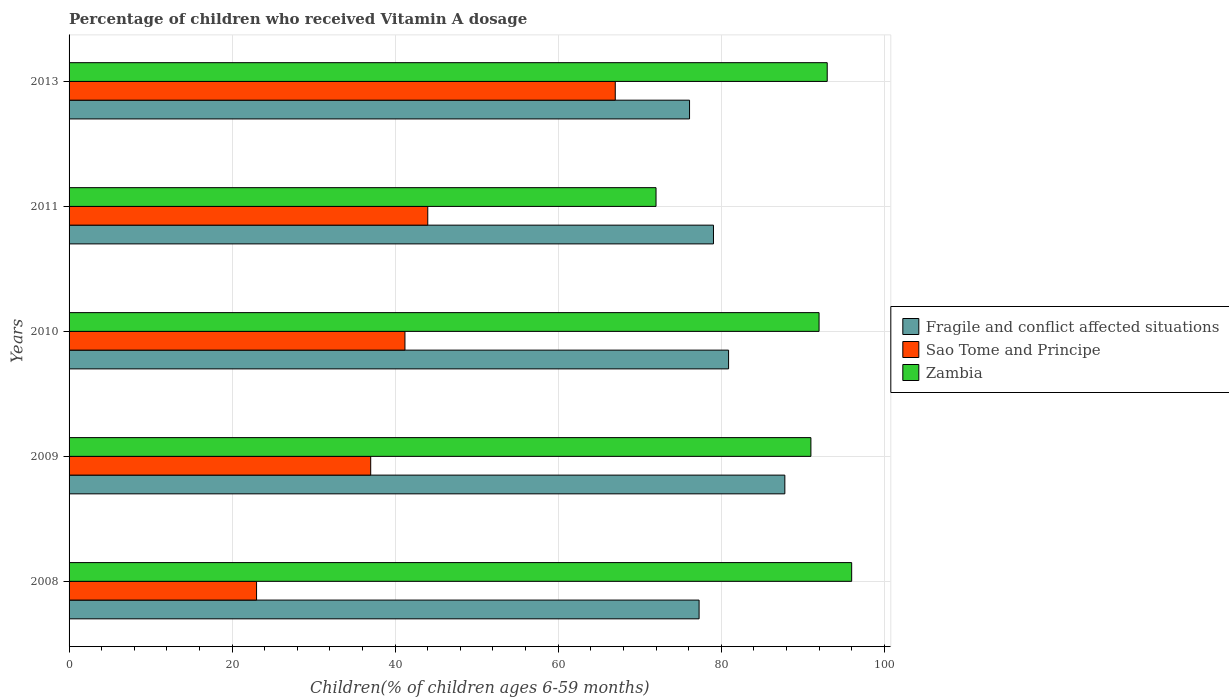How many groups of bars are there?
Provide a short and direct response. 5. How many bars are there on the 2nd tick from the top?
Provide a short and direct response. 3. What is the label of the 1st group of bars from the top?
Provide a short and direct response. 2013. Across all years, what is the minimum percentage of children who received Vitamin A dosage in Fragile and conflict affected situations?
Offer a terse response. 76.11. In which year was the percentage of children who received Vitamin A dosage in Sao Tome and Principe maximum?
Offer a very short reply. 2013. What is the total percentage of children who received Vitamin A dosage in Fragile and conflict affected situations in the graph?
Keep it short and to the point. 401.15. What is the difference between the percentage of children who received Vitamin A dosage in Zambia in 2010 and that in 2013?
Offer a very short reply. -1. What is the difference between the percentage of children who received Vitamin A dosage in Zambia in 2009 and the percentage of children who received Vitamin A dosage in Fragile and conflict affected situations in 2008?
Offer a terse response. 13.72. What is the average percentage of children who received Vitamin A dosage in Zambia per year?
Provide a succinct answer. 88.8. In the year 2011, what is the difference between the percentage of children who received Vitamin A dosage in Zambia and percentage of children who received Vitamin A dosage in Fragile and conflict affected situations?
Provide a short and direct response. -7.05. What is the ratio of the percentage of children who received Vitamin A dosage in Fragile and conflict affected situations in 2008 to that in 2009?
Your response must be concise. 0.88. Is the percentage of children who received Vitamin A dosage in Sao Tome and Principe in 2008 less than that in 2009?
Provide a short and direct response. Yes. What is the difference between the highest and the second highest percentage of children who received Vitamin A dosage in Fragile and conflict affected situations?
Offer a very short reply. 6.9. Is the sum of the percentage of children who received Vitamin A dosage in Zambia in 2008 and 2010 greater than the maximum percentage of children who received Vitamin A dosage in Fragile and conflict affected situations across all years?
Give a very brief answer. Yes. What does the 3rd bar from the top in 2010 represents?
Provide a succinct answer. Fragile and conflict affected situations. What does the 2nd bar from the bottom in 2011 represents?
Make the answer very short. Sao Tome and Principe. Is it the case that in every year, the sum of the percentage of children who received Vitamin A dosage in Zambia and percentage of children who received Vitamin A dosage in Fragile and conflict affected situations is greater than the percentage of children who received Vitamin A dosage in Sao Tome and Principe?
Provide a short and direct response. Yes. How many bars are there?
Offer a terse response. 15. How many years are there in the graph?
Your answer should be compact. 5. What is the difference between two consecutive major ticks on the X-axis?
Give a very brief answer. 20. Does the graph contain any zero values?
Offer a terse response. No. Where does the legend appear in the graph?
Keep it short and to the point. Center right. How are the legend labels stacked?
Your answer should be compact. Vertical. What is the title of the graph?
Your answer should be very brief. Percentage of children who received Vitamin A dosage. Does "South Asia" appear as one of the legend labels in the graph?
Offer a terse response. No. What is the label or title of the X-axis?
Keep it short and to the point. Children(% of children ages 6-59 months). What is the Children(% of children ages 6-59 months) of Fragile and conflict affected situations in 2008?
Make the answer very short. 77.28. What is the Children(% of children ages 6-59 months) of Zambia in 2008?
Your answer should be very brief. 96. What is the Children(% of children ages 6-59 months) of Fragile and conflict affected situations in 2009?
Your response must be concise. 87.8. What is the Children(% of children ages 6-59 months) of Zambia in 2009?
Offer a very short reply. 91. What is the Children(% of children ages 6-59 months) in Fragile and conflict affected situations in 2010?
Your response must be concise. 80.9. What is the Children(% of children ages 6-59 months) of Sao Tome and Principe in 2010?
Your answer should be compact. 41.2. What is the Children(% of children ages 6-59 months) in Zambia in 2010?
Provide a short and direct response. 92. What is the Children(% of children ages 6-59 months) of Fragile and conflict affected situations in 2011?
Ensure brevity in your answer.  79.05. What is the Children(% of children ages 6-59 months) of Zambia in 2011?
Make the answer very short. 72. What is the Children(% of children ages 6-59 months) of Fragile and conflict affected situations in 2013?
Your answer should be compact. 76.11. What is the Children(% of children ages 6-59 months) of Sao Tome and Principe in 2013?
Your response must be concise. 67. What is the Children(% of children ages 6-59 months) of Zambia in 2013?
Provide a short and direct response. 93. Across all years, what is the maximum Children(% of children ages 6-59 months) in Fragile and conflict affected situations?
Your response must be concise. 87.8. Across all years, what is the maximum Children(% of children ages 6-59 months) of Sao Tome and Principe?
Keep it short and to the point. 67. Across all years, what is the maximum Children(% of children ages 6-59 months) in Zambia?
Give a very brief answer. 96. Across all years, what is the minimum Children(% of children ages 6-59 months) of Fragile and conflict affected situations?
Make the answer very short. 76.11. Across all years, what is the minimum Children(% of children ages 6-59 months) in Zambia?
Your answer should be compact. 72. What is the total Children(% of children ages 6-59 months) of Fragile and conflict affected situations in the graph?
Offer a terse response. 401.15. What is the total Children(% of children ages 6-59 months) of Sao Tome and Principe in the graph?
Your answer should be compact. 212.2. What is the total Children(% of children ages 6-59 months) of Zambia in the graph?
Offer a very short reply. 444. What is the difference between the Children(% of children ages 6-59 months) in Fragile and conflict affected situations in 2008 and that in 2009?
Offer a very short reply. -10.52. What is the difference between the Children(% of children ages 6-59 months) of Sao Tome and Principe in 2008 and that in 2009?
Your response must be concise. -14. What is the difference between the Children(% of children ages 6-59 months) in Zambia in 2008 and that in 2009?
Give a very brief answer. 5. What is the difference between the Children(% of children ages 6-59 months) in Fragile and conflict affected situations in 2008 and that in 2010?
Your answer should be very brief. -3.62. What is the difference between the Children(% of children ages 6-59 months) of Sao Tome and Principe in 2008 and that in 2010?
Keep it short and to the point. -18.2. What is the difference between the Children(% of children ages 6-59 months) of Fragile and conflict affected situations in 2008 and that in 2011?
Give a very brief answer. -1.76. What is the difference between the Children(% of children ages 6-59 months) in Sao Tome and Principe in 2008 and that in 2011?
Your answer should be very brief. -21. What is the difference between the Children(% of children ages 6-59 months) in Fragile and conflict affected situations in 2008 and that in 2013?
Give a very brief answer. 1.17. What is the difference between the Children(% of children ages 6-59 months) in Sao Tome and Principe in 2008 and that in 2013?
Offer a very short reply. -44. What is the difference between the Children(% of children ages 6-59 months) in Fragile and conflict affected situations in 2009 and that in 2010?
Offer a terse response. 6.9. What is the difference between the Children(% of children ages 6-59 months) of Sao Tome and Principe in 2009 and that in 2010?
Give a very brief answer. -4.2. What is the difference between the Children(% of children ages 6-59 months) of Zambia in 2009 and that in 2010?
Your response must be concise. -1. What is the difference between the Children(% of children ages 6-59 months) in Fragile and conflict affected situations in 2009 and that in 2011?
Your answer should be compact. 8.76. What is the difference between the Children(% of children ages 6-59 months) in Sao Tome and Principe in 2009 and that in 2011?
Provide a short and direct response. -7. What is the difference between the Children(% of children ages 6-59 months) of Zambia in 2009 and that in 2011?
Make the answer very short. 19. What is the difference between the Children(% of children ages 6-59 months) of Fragile and conflict affected situations in 2009 and that in 2013?
Offer a terse response. 11.69. What is the difference between the Children(% of children ages 6-59 months) in Sao Tome and Principe in 2009 and that in 2013?
Your answer should be very brief. -30. What is the difference between the Children(% of children ages 6-59 months) of Fragile and conflict affected situations in 2010 and that in 2011?
Provide a succinct answer. 1.85. What is the difference between the Children(% of children ages 6-59 months) in Sao Tome and Principe in 2010 and that in 2011?
Provide a short and direct response. -2.8. What is the difference between the Children(% of children ages 6-59 months) in Fragile and conflict affected situations in 2010 and that in 2013?
Your answer should be compact. 4.79. What is the difference between the Children(% of children ages 6-59 months) in Sao Tome and Principe in 2010 and that in 2013?
Your answer should be compact. -25.8. What is the difference between the Children(% of children ages 6-59 months) of Fragile and conflict affected situations in 2011 and that in 2013?
Offer a terse response. 2.93. What is the difference between the Children(% of children ages 6-59 months) in Sao Tome and Principe in 2011 and that in 2013?
Offer a terse response. -23. What is the difference between the Children(% of children ages 6-59 months) in Fragile and conflict affected situations in 2008 and the Children(% of children ages 6-59 months) in Sao Tome and Principe in 2009?
Give a very brief answer. 40.28. What is the difference between the Children(% of children ages 6-59 months) of Fragile and conflict affected situations in 2008 and the Children(% of children ages 6-59 months) of Zambia in 2009?
Give a very brief answer. -13.72. What is the difference between the Children(% of children ages 6-59 months) in Sao Tome and Principe in 2008 and the Children(% of children ages 6-59 months) in Zambia in 2009?
Offer a very short reply. -68. What is the difference between the Children(% of children ages 6-59 months) in Fragile and conflict affected situations in 2008 and the Children(% of children ages 6-59 months) in Sao Tome and Principe in 2010?
Provide a short and direct response. 36.08. What is the difference between the Children(% of children ages 6-59 months) of Fragile and conflict affected situations in 2008 and the Children(% of children ages 6-59 months) of Zambia in 2010?
Provide a short and direct response. -14.72. What is the difference between the Children(% of children ages 6-59 months) in Sao Tome and Principe in 2008 and the Children(% of children ages 6-59 months) in Zambia in 2010?
Offer a very short reply. -69. What is the difference between the Children(% of children ages 6-59 months) of Fragile and conflict affected situations in 2008 and the Children(% of children ages 6-59 months) of Sao Tome and Principe in 2011?
Provide a short and direct response. 33.28. What is the difference between the Children(% of children ages 6-59 months) of Fragile and conflict affected situations in 2008 and the Children(% of children ages 6-59 months) of Zambia in 2011?
Give a very brief answer. 5.28. What is the difference between the Children(% of children ages 6-59 months) in Sao Tome and Principe in 2008 and the Children(% of children ages 6-59 months) in Zambia in 2011?
Give a very brief answer. -49. What is the difference between the Children(% of children ages 6-59 months) of Fragile and conflict affected situations in 2008 and the Children(% of children ages 6-59 months) of Sao Tome and Principe in 2013?
Keep it short and to the point. 10.28. What is the difference between the Children(% of children ages 6-59 months) of Fragile and conflict affected situations in 2008 and the Children(% of children ages 6-59 months) of Zambia in 2013?
Ensure brevity in your answer.  -15.72. What is the difference between the Children(% of children ages 6-59 months) of Sao Tome and Principe in 2008 and the Children(% of children ages 6-59 months) of Zambia in 2013?
Provide a succinct answer. -70. What is the difference between the Children(% of children ages 6-59 months) of Fragile and conflict affected situations in 2009 and the Children(% of children ages 6-59 months) of Sao Tome and Principe in 2010?
Make the answer very short. 46.6. What is the difference between the Children(% of children ages 6-59 months) of Fragile and conflict affected situations in 2009 and the Children(% of children ages 6-59 months) of Zambia in 2010?
Provide a short and direct response. -4.2. What is the difference between the Children(% of children ages 6-59 months) in Sao Tome and Principe in 2009 and the Children(% of children ages 6-59 months) in Zambia in 2010?
Ensure brevity in your answer.  -55. What is the difference between the Children(% of children ages 6-59 months) in Fragile and conflict affected situations in 2009 and the Children(% of children ages 6-59 months) in Sao Tome and Principe in 2011?
Your response must be concise. 43.8. What is the difference between the Children(% of children ages 6-59 months) in Fragile and conflict affected situations in 2009 and the Children(% of children ages 6-59 months) in Zambia in 2011?
Offer a terse response. 15.8. What is the difference between the Children(% of children ages 6-59 months) of Sao Tome and Principe in 2009 and the Children(% of children ages 6-59 months) of Zambia in 2011?
Provide a short and direct response. -35. What is the difference between the Children(% of children ages 6-59 months) of Fragile and conflict affected situations in 2009 and the Children(% of children ages 6-59 months) of Sao Tome and Principe in 2013?
Provide a short and direct response. 20.8. What is the difference between the Children(% of children ages 6-59 months) in Fragile and conflict affected situations in 2009 and the Children(% of children ages 6-59 months) in Zambia in 2013?
Your answer should be very brief. -5.2. What is the difference between the Children(% of children ages 6-59 months) of Sao Tome and Principe in 2009 and the Children(% of children ages 6-59 months) of Zambia in 2013?
Ensure brevity in your answer.  -56. What is the difference between the Children(% of children ages 6-59 months) of Fragile and conflict affected situations in 2010 and the Children(% of children ages 6-59 months) of Sao Tome and Principe in 2011?
Provide a succinct answer. 36.9. What is the difference between the Children(% of children ages 6-59 months) of Fragile and conflict affected situations in 2010 and the Children(% of children ages 6-59 months) of Zambia in 2011?
Make the answer very short. 8.9. What is the difference between the Children(% of children ages 6-59 months) of Sao Tome and Principe in 2010 and the Children(% of children ages 6-59 months) of Zambia in 2011?
Keep it short and to the point. -30.8. What is the difference between the Children(% of children ages 6-59 months) in Fragile and conflict affected situations in 2010 and the Children(% of children ages 6-59 months) in Sao Tome and Principe in 2013?
Offer a terse response. 13.9. What is the difference between the Children(% of children ages 6-59 months) in Fragile and conflict affected situations in 2010 and the Children(% of children ages 6-59 months) in Zambia in 2013?
Provide a short and direct response. -12.1. What is the difference between the Children(% of children ages 6-59 months) of Sao Tome and Principe in 2010 and the Children(% of children ages 6-59 months) of Zambia in 2013?
Give a very brief answer. -51.8. What is the difference between the Children(% of children ages 6-59 months) of Fragile and conflict affected situations in 2011 and the Children(% of children ages 6-59 months) of Sao Tome and Principe in 2013?
Your response must be concise. 12.05. What is the difference between the Children(% of children ages 6-59 months) of Fragile and conflict affected situations in 2011 and the Children(% of children ages 6-59 months) of Zambia in 2013?
Your answer should be compact. -13.95. What is the difference between the Children(% of children ages 6-59 months) in Sao Tome and Principe in 2011 and the Children(% of children ages 6-59 months) in Zambia in 2013?
Offer a terse response. -49. What is the average Children(% of children ages 6-59 months) of Fragile and conflict affected situations per year?
Offer a terse response. 80.23. What is the average Children(% of children ages 6-59 months) of Sao Tome and Principe per year?
Provide a short and direct response. 42.44. What is the average Children(% of children ages 6-59 months) of Zambia per year?
Make the answer very short. 88.8. In the year 2008, what is the difference between the Children(% of children ages 6-59 months) of Fragile and conflict affected situations and Children(% of children ages 6-59 months) of Sao Tome and Principe?
Offer a terse response. 54.28. In the year 2008, what is the difference between the Children(% of children ages 6-59 months) of Fragile and conflict affected situations and Children(% of children ages 6-59 months) of Zambia?
Offer a very short reply. -18.72. In the year 2008, what is the difference between the Children(% of children ages 6-59 months) in Sao Tome and Principe and Children(% of children ages 6-59 months) in Zambia?
Your response must be concise. -73. In the year 2009, what is the difference between the Children(% of children ages 6-59 months) of Fragile and conflict affected situations and Children(% of children ages 6-59 months) of Sao Tome and Principe?
Provide a short and direct response. 50.8. In the year 2009, what is the difference between the Children(% of children ages 6-59 months) in Fragile and conflict affected situations and Children(% of children ages 6-59 months) in Zambia?
Offer a very short reply. -3.2. In the year 2009, what is the difference between the Children(% of children ages 6-59 months) in Sao Tome and Principe and Children(% of children ages 6-59 months) in Zambia?
Provide a short and direct response. -54. In the year 2010, what is the difference between the Children(% of children ages 6-59 months) in Fragile and conflict affected situations and Children(% of children ages 6-59 months) in Sao Tome and Principe?
Make the answer very short. 39.7. In the year 2010, what is the difference between the Children(% of children ages 6-59 months) of Fragile and conflict affected situations and Children(% of children ages 6-59 months) of Zambia?
Ensure brevity in your answer.  -11.1. In the year 2010, what is the difference between the Children(% of children ages 6-59 months) in Sao Tome and Principe and Children(% of children ages 6-59 months) in Zambia?
Make the answer very short. -50.8. In the year 2011, what is the difference between the Children(% of children ages 6-59 months) in Fragile and conflict affected situations and Children(% of children ages 6-59 months) in Sao Tome and Principe?
Provide a succinct answer. 35.05. In the year 2011, what is the difference between the Children(% of children ages 6-59 months) in Fragile and conflict affected situations and Children(% of children ages 6-59 months) in Zambia?
Give a very brief answer. 7.05. In the year 2013, what is the difference between the Children(% of children ages 6-59 months) in Fragile and conflict affected situations and Children(% of children ages 6-59 months) in Sao Tome and Principe?
Provide a succinct answer. 9.11. In the year 2013, what is the difference between the Children(% of children ages 6-59 months) in Fragile and conflict affected situations and Children(% of children ages 6-59 months) in Zambia?
Make the answer very short. -16.89. What is the ratio of the Children(% of children ages 6-59 months) of Fragile and conflict affected situations in 2008 to that in 2009?
Your response must be concise. 0.88. What is the ratio of the Children(% of children ages 6-59 months) in Sao Tome and Principe in 2008 to that in 2009?
Offer a terse response. 0.62. What is the ratio of the Children(% of children ages 6-59 months) in Zambia in 2008 to that in 2009?
Provide a succinct answer. 1.05. What is the ratio of the Children(% of children ages 6-59 months) of Fragile and conflict affected situations in 2008 to that in 2010?
Offer a very short reply. 0.96. What is the ratio of the Children(% of children ages 6-59 months) of Sao Tome and Principe in 2008 to that in 2010?
Ensure brevity in your answer.  0.56. What is the ratio of the Children(% of children ages 6-59 months) of Zambia in 2008 to that in 2010?
Offer a terse response. 1.04. What is the ratio of the Children(% of children ages 6-59 months) in Fragile and conflict affected situations in 2008 to that in 2011?
Keep it short and to the point. 0.98. What is the ratio of the Children(% of children ages 6-59 months) of Sao Tome and Principe in 2008 to that in 2011?
Keep it short and to the point. 0.52. What is the ratio of the Children(% of children ages 6-59 months) of Fragile and conflict affected situations in 2008 to that in 2013?
Make the answer very short. 1.02. What is the ratio of the Children(% of children ages 6-59 months) of Sao Tome and Principe in 2008 to that in 2013?
Make the answer very short. 0.34. What is the ratio of the Children(% of children ages 6-59 months) in Zambia in 2008 to that in 2013?
Offer a very short reply. 1.03. What is the ratio of the Children(% of children ages 6-59 months) in Fragile and conflict affected situations in 2009 to that in 2010?
Your response must be concise. 1.09. What is the ratio of the Children(% of children ages 6-59 months) of Sao Tome and Principe in 2009 to that in 2010?
Offer a terse response. 0.9. What is the ratio of the Children(% of children ages 6-59 months) in Zambia in 2009 to that in 2010?
Ensure brevity in your answer.  0.99. What is the ratio of the Children(% of children ages 6-59 months) of Fragile and conflict affected situations in 2009 to that in 2011?
Your response must be concise. 1.11. What is the ratio of the Children(% of children ages 6-59 months) of Sao Tome and Principe in 2009 to that in 2011?
Make the answer very short. 0.84. What is the ratio of the Children(% of children ages 6-59 months) in Zambia in 2009 to that in 2011?
Your answer should be compact. 1.26. What is the ratio of the Children(% of children ages 6-59 months) of Fragile and conflict affected situations in 2009 to that in 2013?
Provide a succinct answer. 1.15. What is the ratio of the Children(% of children ages 6-59 months) in Sao Tome and Principe in 2009 to that in 2013?
Offer a terse response. 0.55. What is the ratio of the Children(% of children ages 6-59 months) in Zambia in 2009 to that in 2013?
Provide a short and direct response. 0.98. What is the ratio of the Children(% of children ages 6-59 months) of Fragile and conflict affected situations in 2010 to that in 2011?
Make the answer very short. 1.02. What is the ratio of the Children(% of children ages 6-59 months) of Sao Tome and Principe in 2010 to that in 2011?
Keep it short and to the point. 0.94. What is the ratio of the Children(% of children ages 6-59 months) in Zambia in 2010 to that in 2011?
Offer a very short reply. 1.28. What is the ratio of the Children(% of children ages 6-59 months) of Fragile and conflict affected situations in 2010 to that in 2013?
Your answer should be very brief. 1.06. What is the ratio of the Children(% of children ages 6-59 months) in Sao Tome and Principe in 2010 to that in 2013?
Give a very brief answer. 0.61. What is the ratio of the Children(% of children ages 6-59 months) in Fragile and conflict affected situations in 2011 to that in 2013?
Give a very brief answer. 1.04. What is the ratio of the Children(% of children ages 6-59 months) in Sao Tome and Principe in 2011 to that in 2013?
Offer a terse response. 0.66. What is the ratio of the Children(% of children ages 6-59 months) in Zambia in 2011 to that in 2013?
Your answer should be compact. 0.77. What is the difference between the highest and the second highest Children(% of children ages 6-59 months) of Fragile and conflict affected situations?
Your answer should be compact. 6.9. What is the difference between the highest and the second highest Children(% of children ages 6-59 months) of Sao Tome and Principe?
Your answer should be compact. 23. What is the difference between the highest and the second highest Children(% of children ages 6-59 months) in Zambia?
Give a very brief answer. 3. What is the difference between the highest and the lowest Children(% of children ages 6-59 months) of Fragile and conflict affected situations?
Give a very brief answer. 11.69. What is the difference between the highest and the lowest Children(% of children ages 6-59 months) of Sao Tome and Principe?
Your answer should be very brief. 44. What is the difference between the highest and the lowest Children(% of children ages 6-59 months) of Zambia?
Provide a short and direct response. 24. 